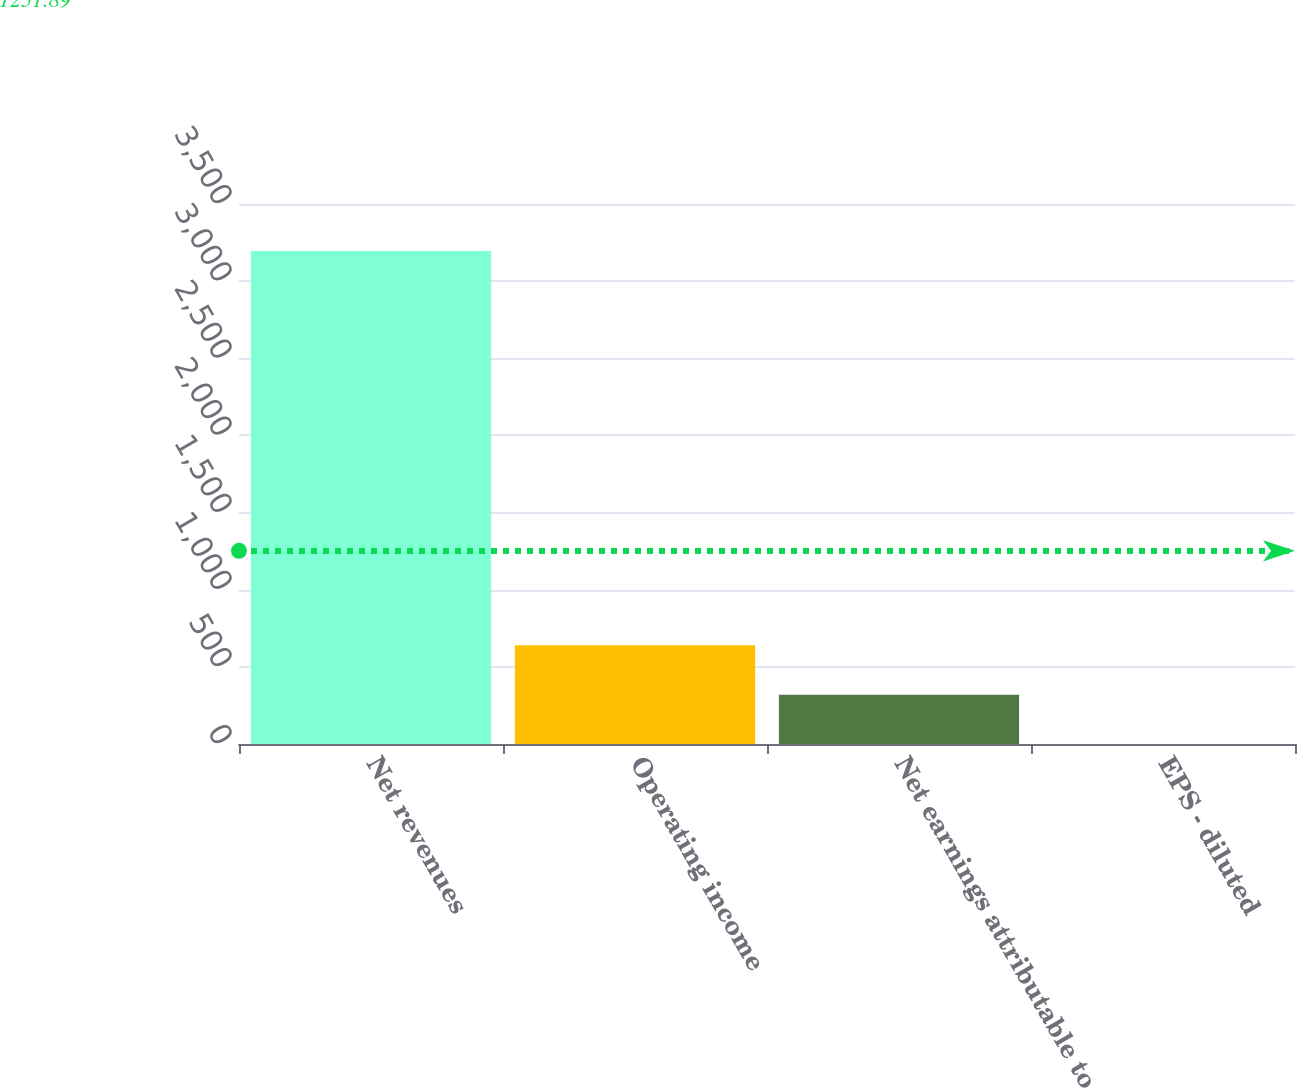Convert chart to OTSL. <chart><loc_0><loc_0><loc_500><loc_500><bar_chart><fcel>Net revenues<fcel>Operating income<fcel>Net earnings attributable to<fcel>EPS - diluted<nl><fcel>3195.9<fcel>639.5<fcel>319.95<fcel>0.4<nl></chart> 